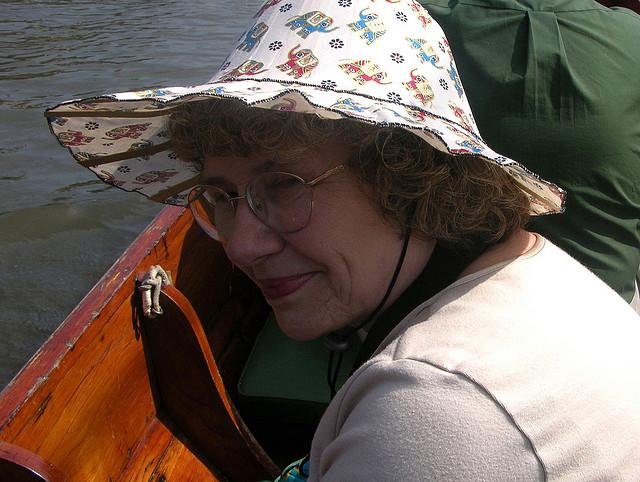Why is she smiling?
Answer briefly. Happy. Is the woman wearing a hat?
Write a very short answer. Yes. Is the woman wearing glasses?
Short answer required. Yes. 